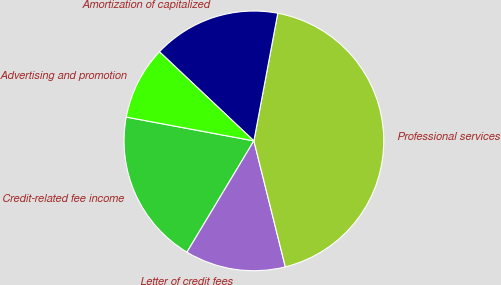<chart> <loc_0><loc_0><loc_500><loc_500><pie_chart><fcel>Credit-related fee income<fcel>Letter of credit fees<fcel>Professional services<fcel>Amortization of capitalized<fcel>Advertising and promotion<nl><fcel>19.32%<fcel>12.51%<fcel>43.17%<fcel>15.91%<fcel>9.1%<nl></chart> 